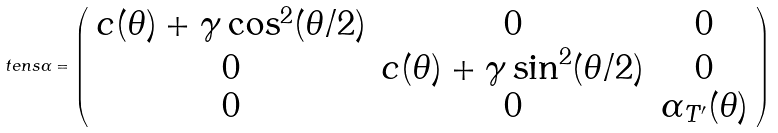Convert formula to latex. <formula><loc_0><loc_0><loc_500><loc_500>\ t e n s { \alpha } = \left ( \begin{array} { c c c } c ( \theta ) + \gamma \cos ^ { 2 } ( \theta / 2 ) & 0 & 0 \\ 0 & c ( \theta ) + \gamma \sin ^ { 2 } ( \theta / 2 ) & 0 \\ 0 & 0 & \alpha _ { T ^ { \prime } } ( \theta ) \end{array} \right )</formula> 